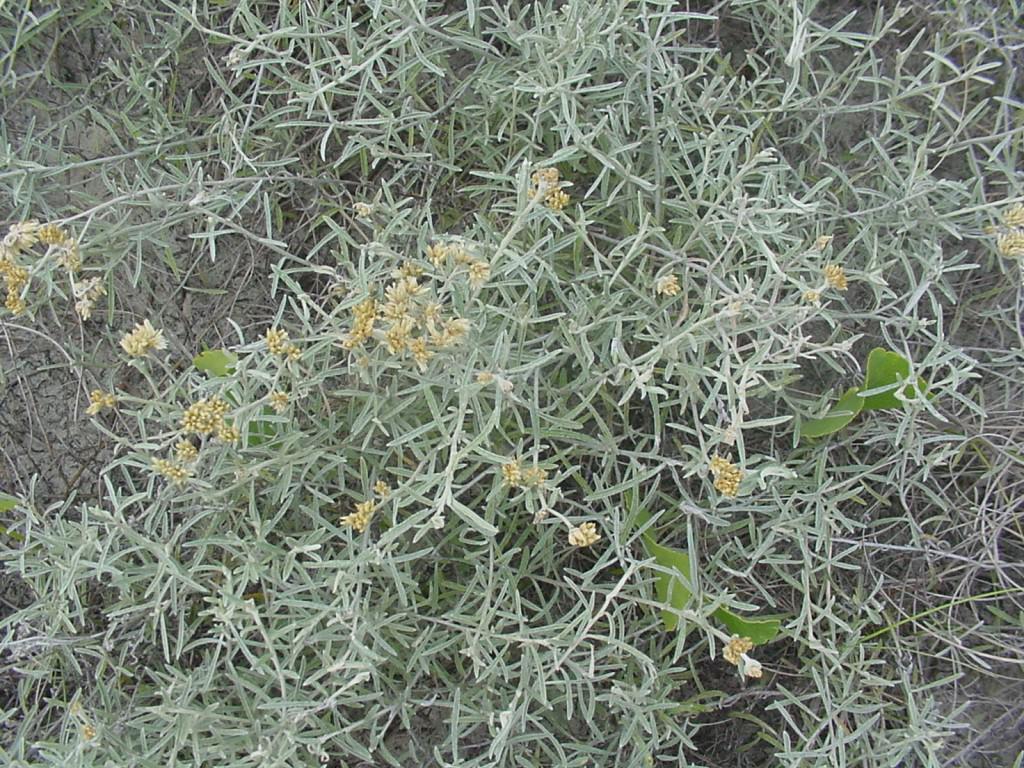Please provide a concise description of this image. In this image, we can see the ground with some plants and flowers. 